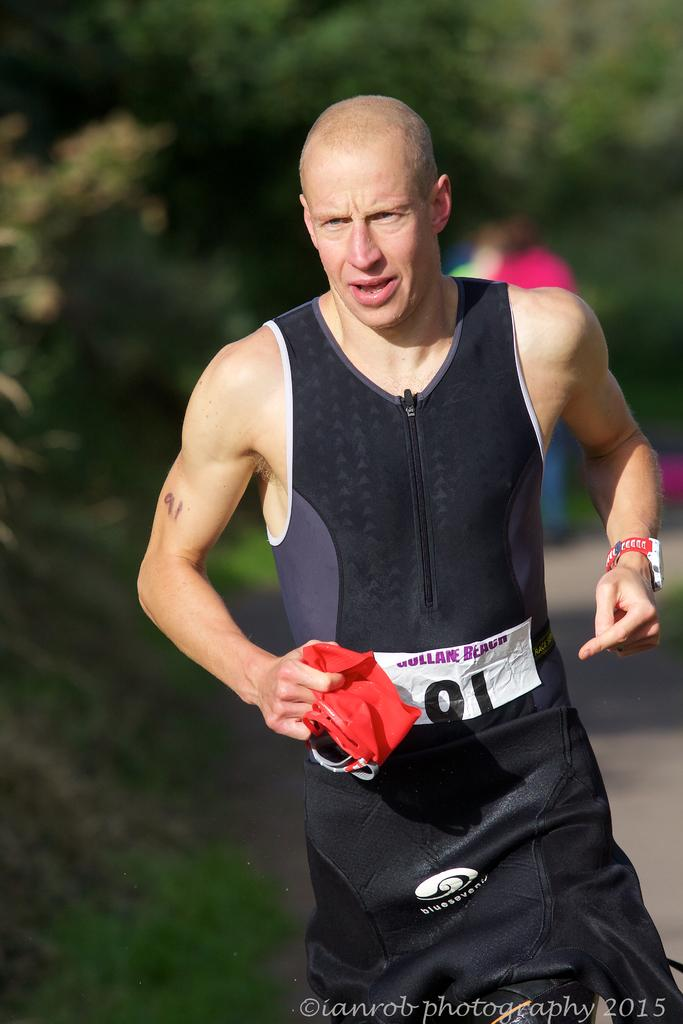Who is present in the image? There is a man in the image. What is the man holding in the image? The man is holding a cloth in the image. What can be seen in the background of the image? There are trees in the background of the image. What activity might the man be engaged in, based on his appearance? The man appears to be a runner. What type of accessory is visible on the man's shirt? There is a badge on the man's shirt. What type of veil is draped over the runner's head in the image? There is no veil present in the image; the man is not wearing any head covering. 